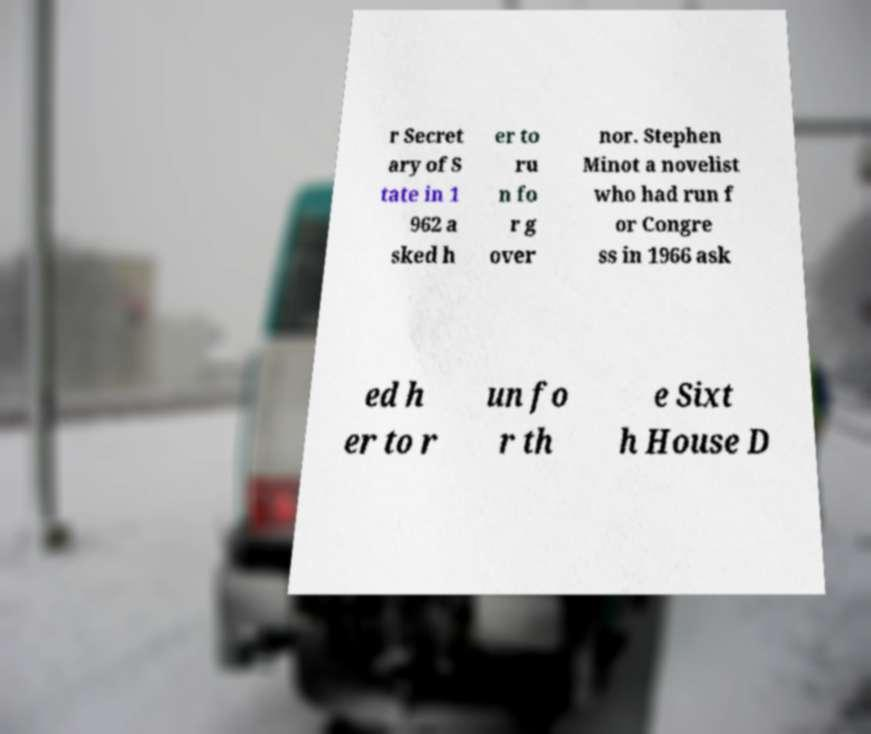Could you assist in decoding the text presented in this image and type it out clearly? r Secret ary of S tate in 1 962 a sked h er to ru n fo r g over nor. Stephen Minot a novelist who had run f or Congre ss in 1966 ask ed h er to r un fo r th e Sixt h House D 